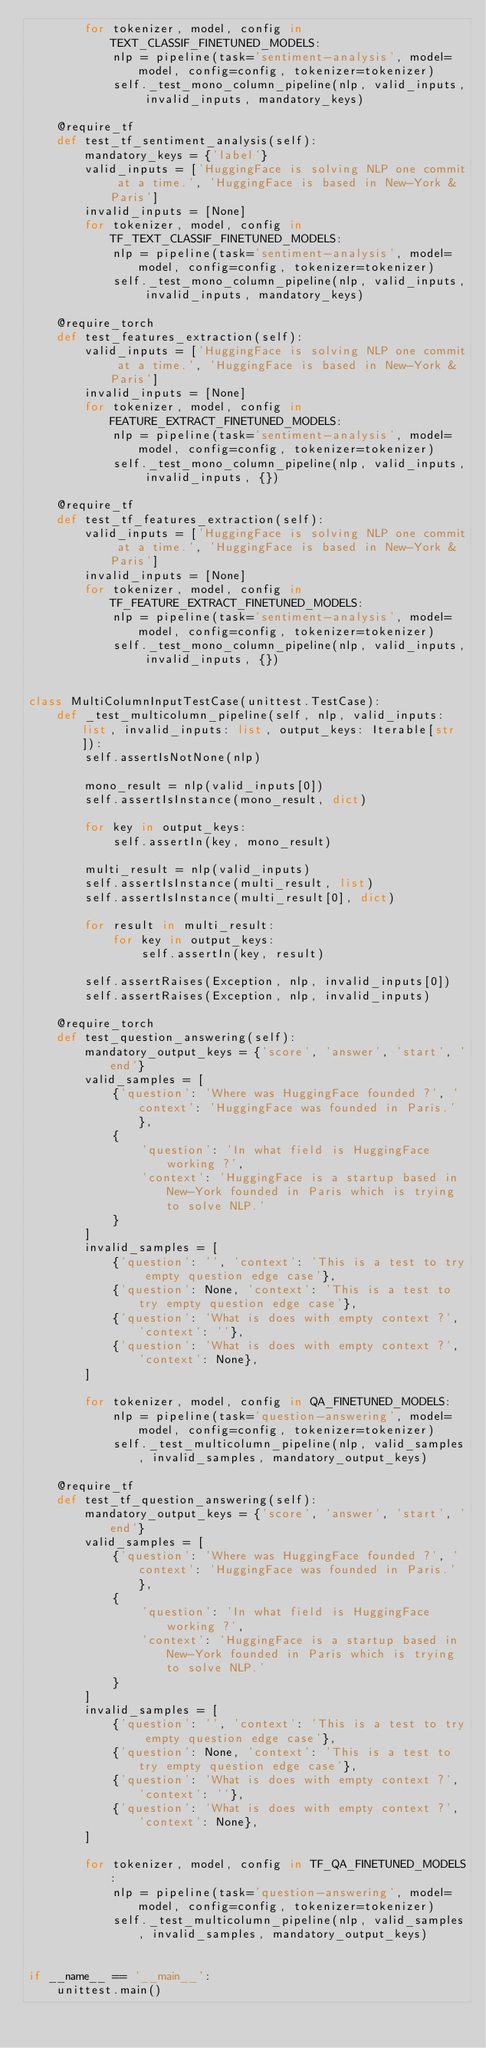Convert code to text. <code><loc_0><loc_0><loc_500><loc_500><_Python_>        for tokenizer, model, config in TEXT_CLASSIF_FINETUNED_MODELS:
            nlp = pipeline(task='sentiment-analysis', model=model, config=config, tokenizer=tokenizer)
            self._test_mono_column_pipeline(nlp, valid_inputs, invalid_inputs, mandatory_keys)

    @require_tf
    def test_tf_sentiment_analysis(self):
        mandatory_keys = {'label'}
        valid_inputs = ['HuggingFace is solving NLP one commit at a time.', 'HuggingFace is based in New-York & Paris']
        invalid_inputs = [None]
        for tokenizer, model, config in TF_TEXT_CLASSIF_FINETUNED_MODELS:
            nlp = pipeline(task='sentiment-analysis', model=model, config=config, tokenizer=tokenizer)
            self._test_mono_column_pipeline(nlp, valid_inputs, invalid_inputs, mandatory_keys)

    @require_torch
    def test_features_extraction(self):
        valid_inputs = ['HuggingFace is solving NLP one commit at a time.', 'HuggingFace is based in New-York & Paris']
        invalid_inputs = [None]
        for tokenizer, model, config in FEATURE_EXTRACT_FINETUNED_MODELS:
            nlp = pipeline(task='sentiment-analysis', model=model, config=config, tokenizer=tokenizer)
            self._test_mono_column_pipeline(nlp, valid_inputs, invalid_inputs, {})

    @require_tf
    def test_tf_features_extraction(self):
        valid_inputs = ['HuggingFace is solving NLP one commit at a time.', 'HuggingFace is based in New-York & Paris']
        invalid_inputs = [None]
        for tokenizer, model, config in TF_FEATURE_EXTRACT_FINETUNED_MODELS:
            nlp = pipeline(task='sentiment-analysis', model=model, config=config, tokenizer=tokenizer)
            self._test_mono_column_pipeline(nlp, valid_inputs, invalid_inputs, {})


class MultiColumnInputTestCase(unittest.TestCase):
    def _test_multicolumn_pipeline(self, nlp, valid_inputs: list, invalid_inputs: list, output_keys: Iterable[str]):
        self.assertIsNotNone(nlp)

        mono_result = nlp(valid_inputs[0])
        self.assertIsInstance(mono_result, dict)

        for key in output_keys:
            self.assertIn(key, mono_result)

        multi_result = nlp(valid_inputs)
        self.assertIsInstance(multi_result, list)
        self.assertIsInstance(multi_result[0], dict)

        for result in multi_result:
            for key in output_keys:
                self.assertIn(key, result)

        self.assertRaises(Exception, nlp, invalid_inputs[0])
        self.assertRaises(Exception, nlp, invalid_inputs)

    @require_torch
    def test_question_answering(self):
        mandatory_output_keys = {'score', 'answer', 'start', 'end'}
        valid_samples = [
            {'question': 'Where was HuggingFace founded ?', 'context': 'HuggingFace was founded in Paris.'},
            {
                'question': 'In what field is HuggingFace working ?',
                'context': 'HuggingFace is a startup based in New-York founded in Paris which is trying to solve NLP.'
            }
        ]
        invalid_samples = [
            {'question': '', 'context': 'This is a test to try empty question edge case'},
            {'question': None, 'context': 'This is a test to try empty question edge case'},
            {'question': 'What is does with empty context ?', 'context': ''},
            {'question': 'What is does with empty context ?', 'context': None},
        ]

        for tokenizer, model, config in QA_FINETUNED_MODELS:
            nlp = pipeline(task='question-answering', model=model, config=config, tokenizer=tokenizer)
            self._test_multicolumn_pipeline(nlp, valid_samples, invalid_samples, mandatory_output_keys)

    @require_tf
    def test_tf_question_answering(self):
        mandatory_output_keys = {'score', 'answer', 'start', 'end'}
        valid_samples = [
            {'question': 'Where was HuggingFace founded ?', 'context': 'HuggingFace was founded in Paris.'},
            {
                'question': 'In what field is HuggingFace working ?',
                'context': 'HuggingFace is a startup based in New-York founded in Paris which is trying to solve NLP.'
            }
        ]
        invalid_samples = [
            {'question': '', 'context': 'This is a test to try empty question edge case'},
            {'question': None, 'context': 'This is a test to try empty question edge case'},
            {'question': 'What is does with empty context ?', 'context': ''},
            {'question': 'What is does with empty context ?', 'context': None},
        ]

        for tokenizer, model, config in TF_QA_FINETUNED_MODELS:
            nlp = pipeline(task='question-answering', model=model, config=config, tokenizer=tokenizer)
            self._test_multicolumn_pipeline(nlp, valid_samples, invalid_samples, mandatory_output_keys)


if __name__ == '__main__':
    unittest.main()
</code> 